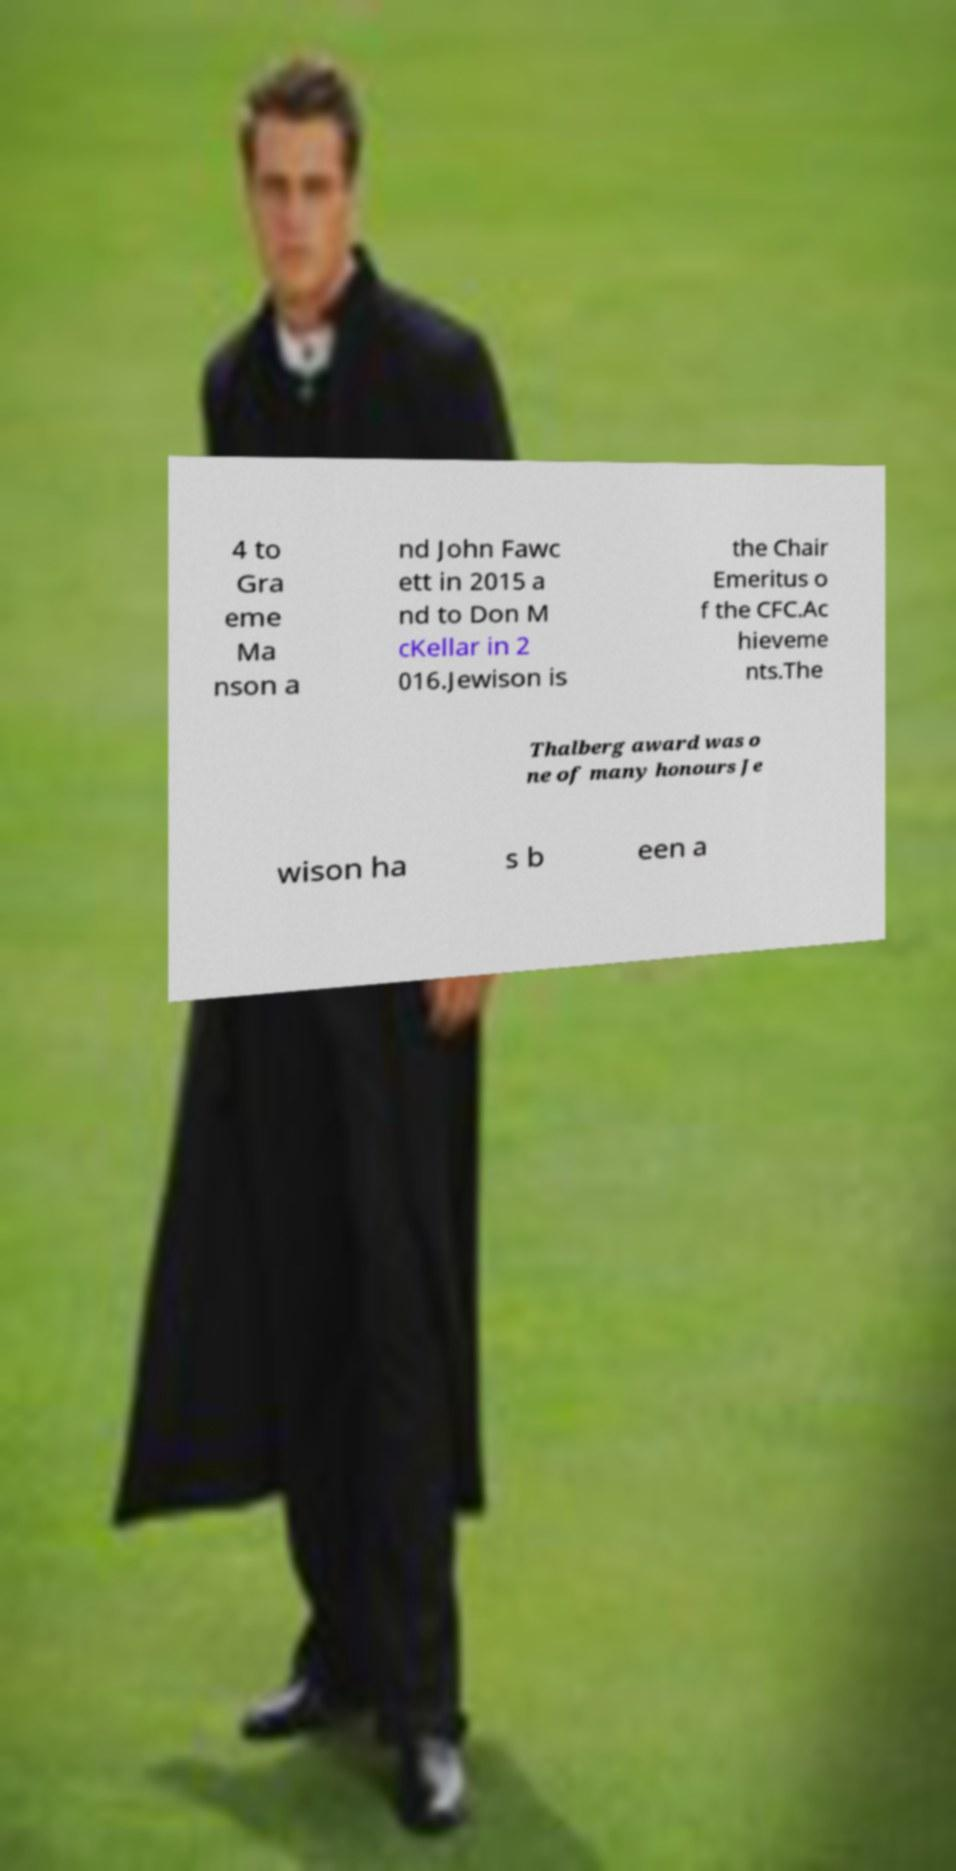Could you extract and type out the text from this image? 4 to Gra eme Ma nson a nd John Fawc ett in 2015 a nd to Don M cKellar in 2 016.Jewison is the Chair Emeritus o f the CFC.Ac hieveme nts.The Thalberg award was o ne of many honours Je wison ha s b een a 